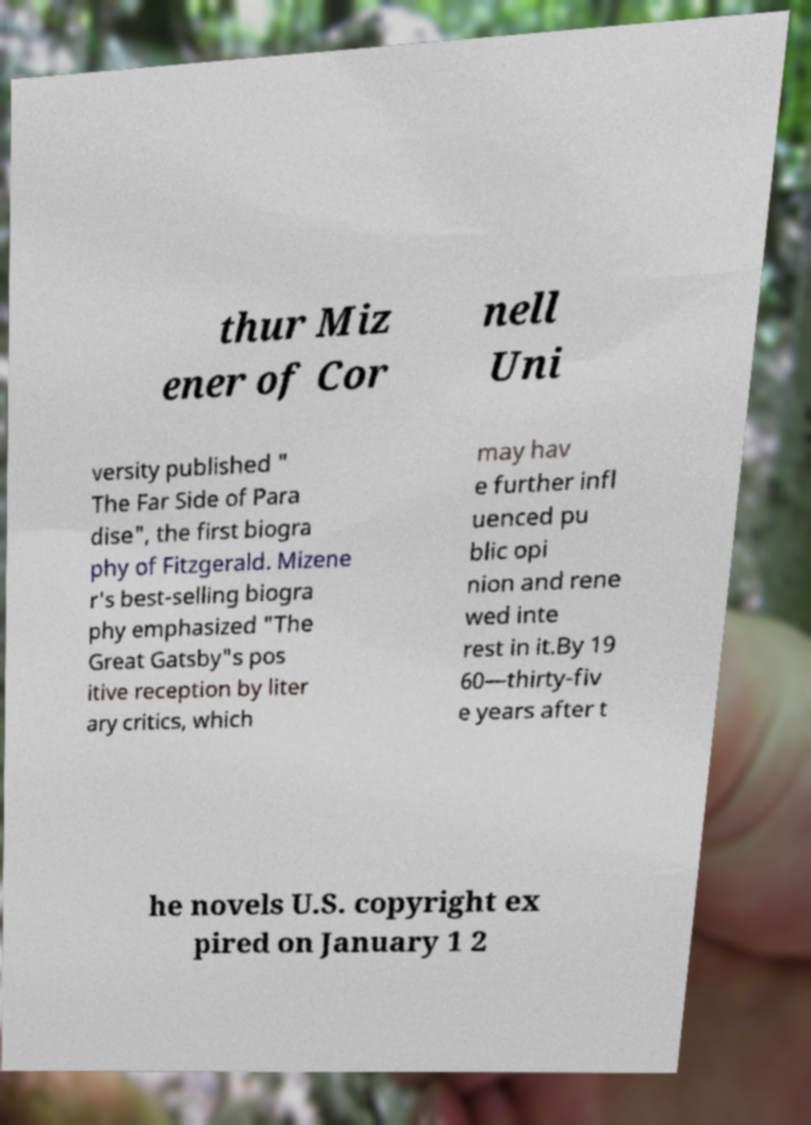For documentation purposes, I need the text within this image transcribed. Could you provide that? thur Miz ener of Cor nell Uni versity published " The Far Side of Para dise", the first biogra phy of Fitzgerald. Mizene r's best-selling biogra phy emphasized "The Great Gatsby"s pos itive reception by liter ary critics, which may hav e further infl uenced pu blic opi nion and rene wed inte rest in it.By 19 60—thirty-fiv e years after t he novels U.S. copyright ex pired on January 1 2 